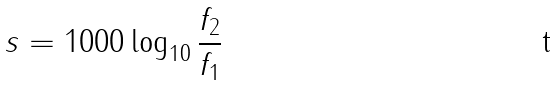Convert formula to latex. <formula><loc_0><loc_0><loc_500><loc_500>s = 1 0 0 0 \log _ { 1 0 } \frac { f _ { 2 } } { f _ { 1 } }</formula> 